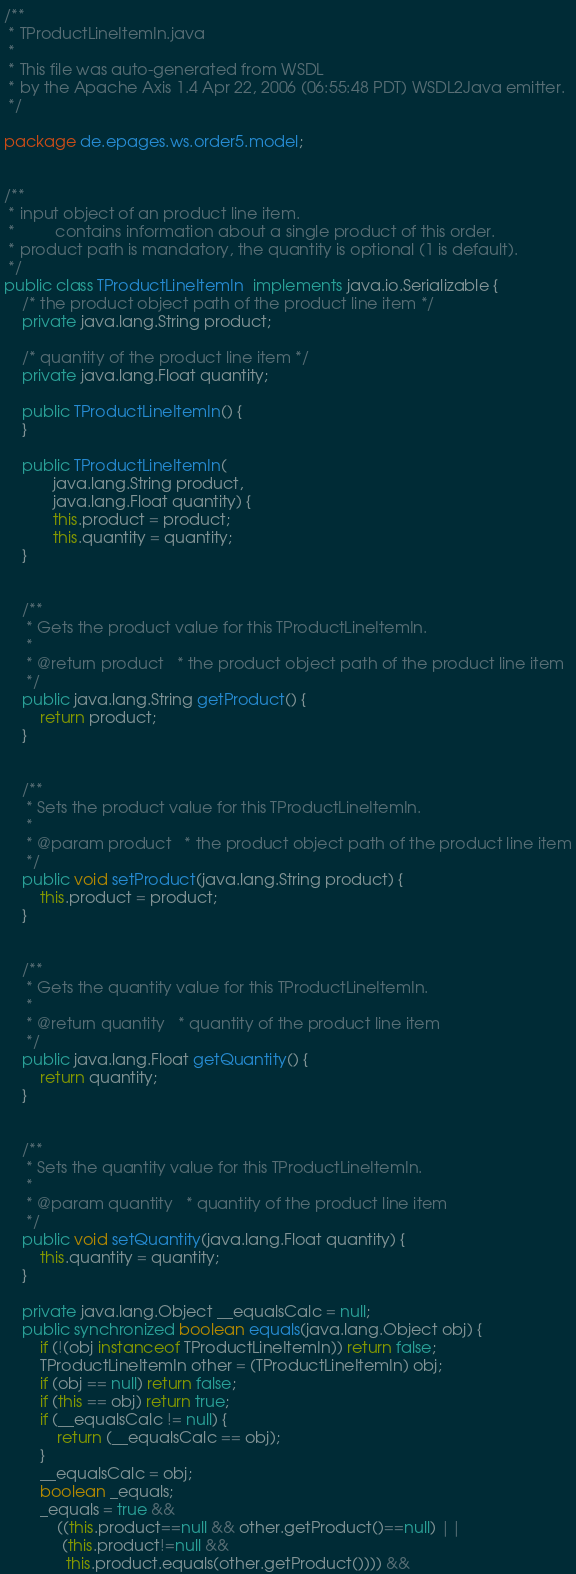Convert code to text. <code><loc_0><loc_0><loc_500><loc_500><_Java_>/**
 * TProductLineItemIn.java
 *
 * This file was auto-generated from WSDL
 * by the Apache Axis 1.4 Apr 22, 2006 (06:55:48 PDT) WSDL2Java emitter.
 */

package de.epages.ws.order5.model;


/**
 * input object of an product line item.
 *         contains information about a single product of this order.
 * product path is mandatory, the quantity is optional (1 is default).
 */
public class TProductLineItemIn  implements java.io.Serializable {
    /* the product object path of the product line item */
    private java.lang.String product;

    /* quantity of the product line item */
    private java.lang.Float quantity;

    public TProductLineItemIn() {
    }

    public TProductLineItemIn(
           java.lang.String product,
           java.lang.Float quantity) {
           this.product = product;
           this.quantity = quantity;
    }


    /**
     * Gets the product value for this TProductLineItemIn.
     * 
     * @return product   * the product object path of the product line item
     */
    public java.lang.String getProduct() {
        return product;
    }


    /**
     * Sets the product value for this TProductLineItemIn.
     * 
     * @param product   * the product object path of the product line item
     */
    public void setProduct(java.lang.String product) {
        this.product = product;
    }


    /**
     * Gets the quantity value for this TProductLineItemIn.
     * 
     * @return quantity   * quantity of the product line item
     */
    public java.lang.Float getQuantity() {
        return quantity;
    }


    /**
     * Sets the quantity value for this TProductLineItemIn.
     * 
     * @param quantity   * quantity of the product line item
     */
    public void setQuantity(java.lang.Float quantity) {
        this.quantity = quantity;
    }

    private java.lang.Object __equalsCalc = null;
    public synchronized boolean equals(java.lang.Object obj) {
        if (!(obj instanceof TProductLineItemIn)) return false;
        TProductLineItemIn other = (TProductLineItemIn) obj;
        if (obj == null) return false;
        if (this == obj) return true;
        if (__equalsCalc != null) {
            return (__equalsCalc == obj);
        }
        __equalsCalc = obj;
        boolean _equals;
        _equals = true && 
            ((this.product==null && other.getProduct()==null) || 
             (this.product!=null &&
              this.product.equals(other.getProduct()))) &&</code> 